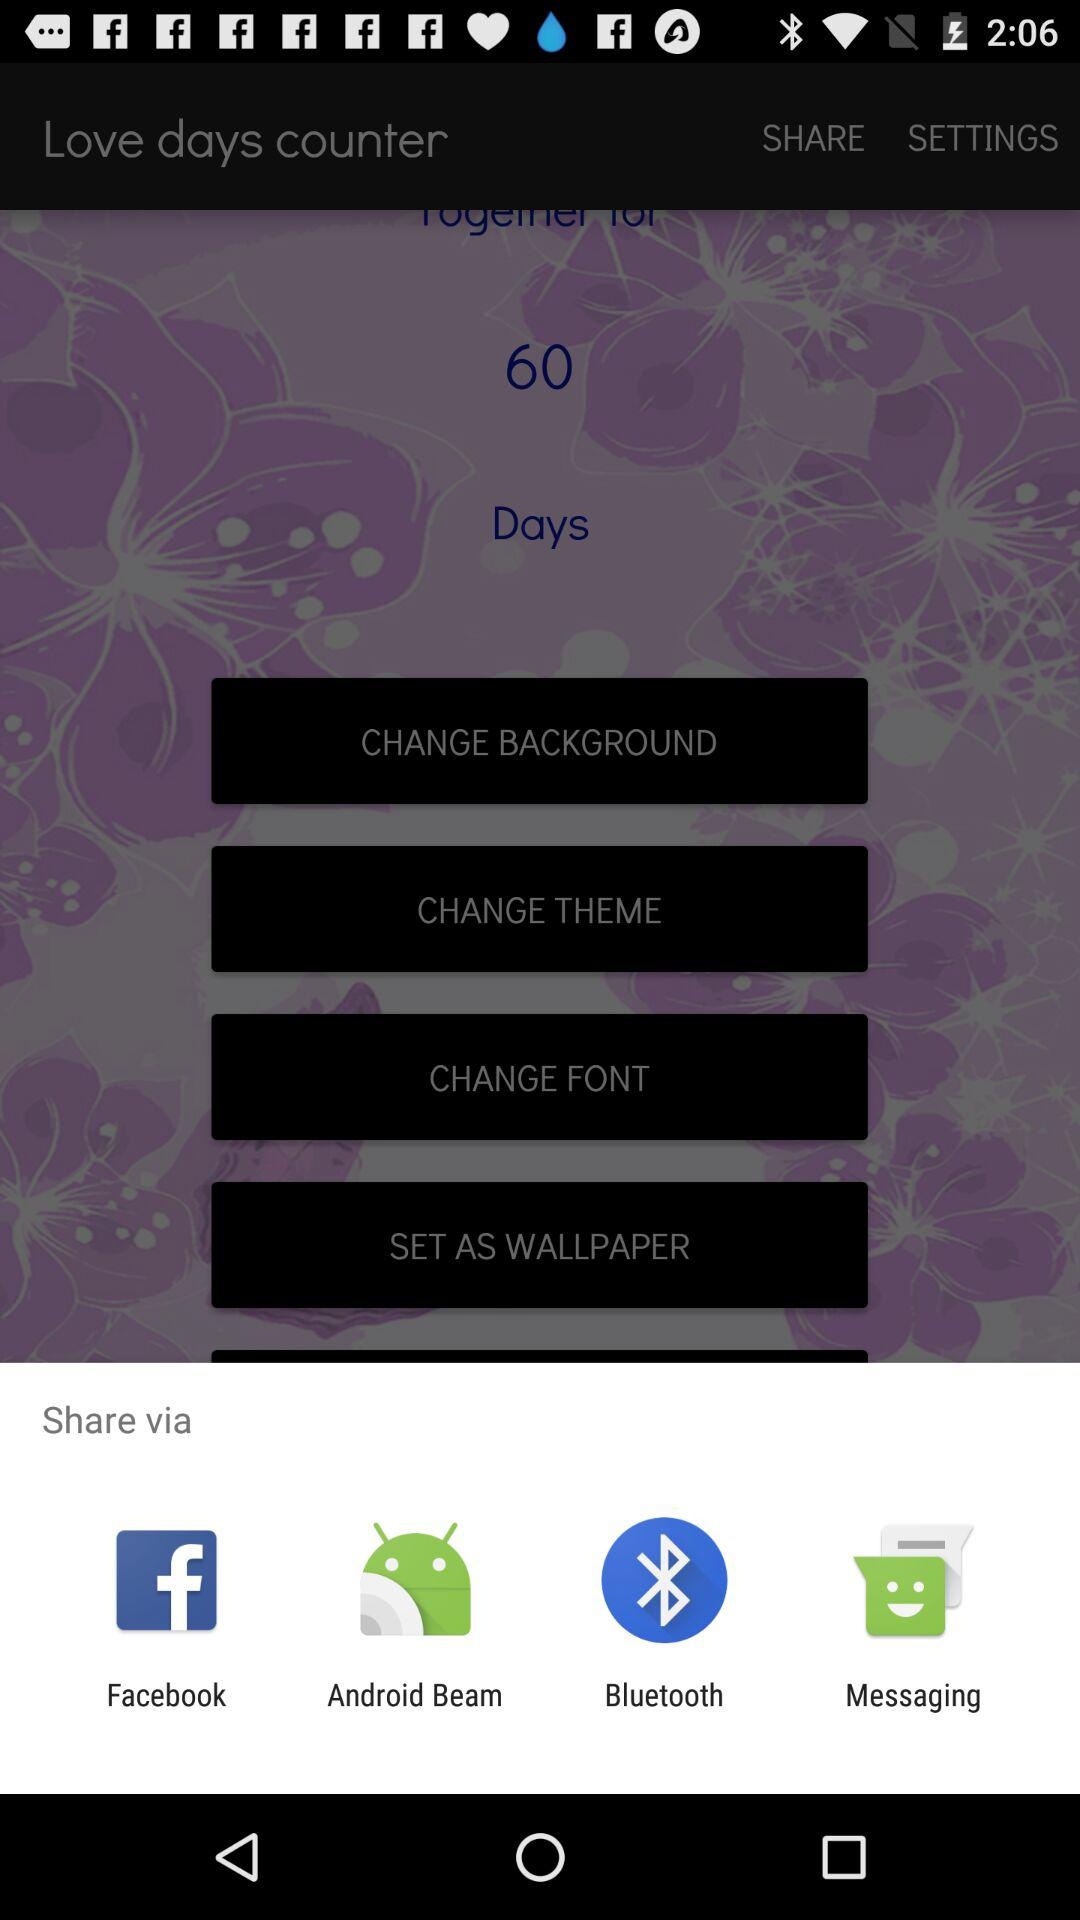How many items are in the share menu?
Answer the question using a single word or phrase. 4 